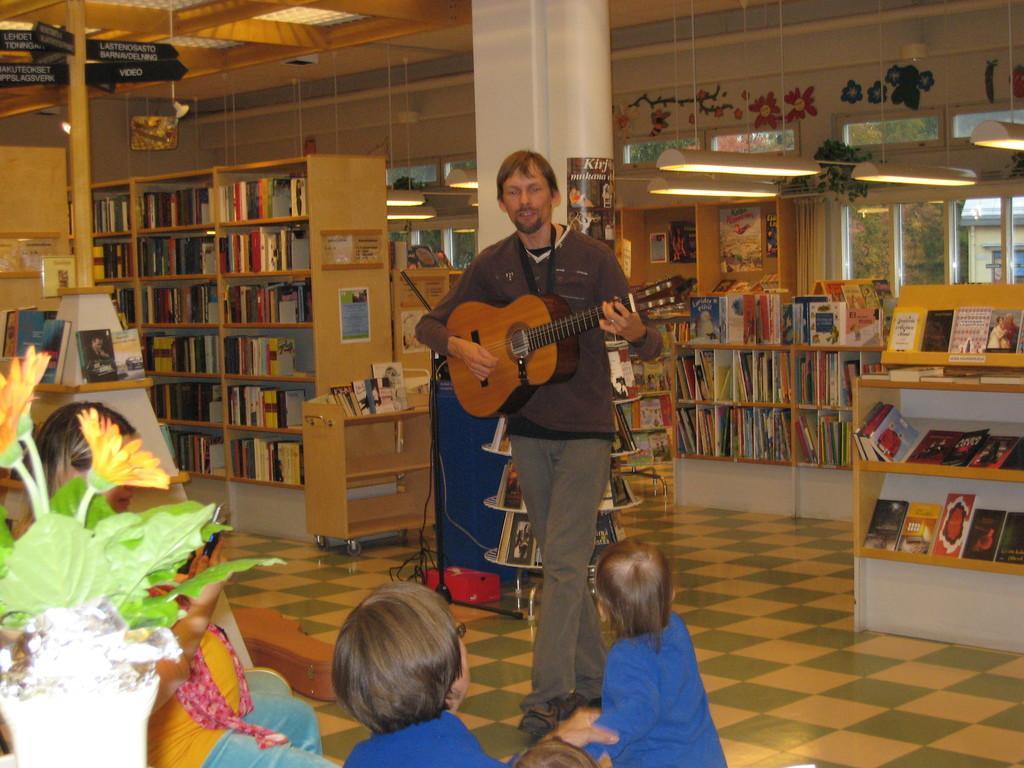Could you give a brief overview of what you see in this image? This picture is taken in a room. In the room there are shelves filled with the books. In the center there is a man playing a guitar. At the bottom there are two kids, wearing blue t-shirts. Beside them there is a woman wearing a yellow top and blue jeans. At the bottom left, there is a flower pot. 